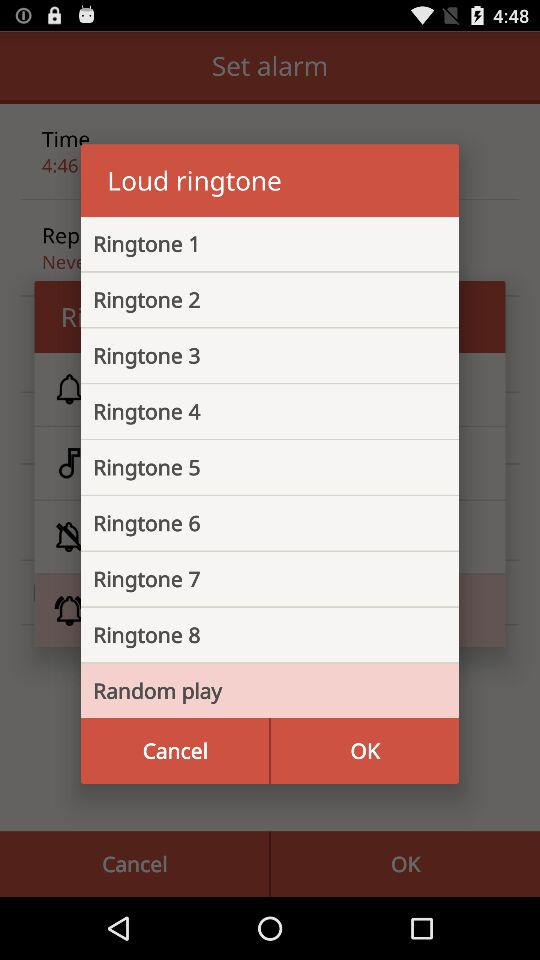What are the available loud ringtones in the list? The available loud ringtones in the list are "Ringtone 1", "Ringtone 2", "Ringtone 3", "Ringtone 4", "Ringtone 5", "Ringtone 6", "Ringtone 7" and "Ringtone 8". 